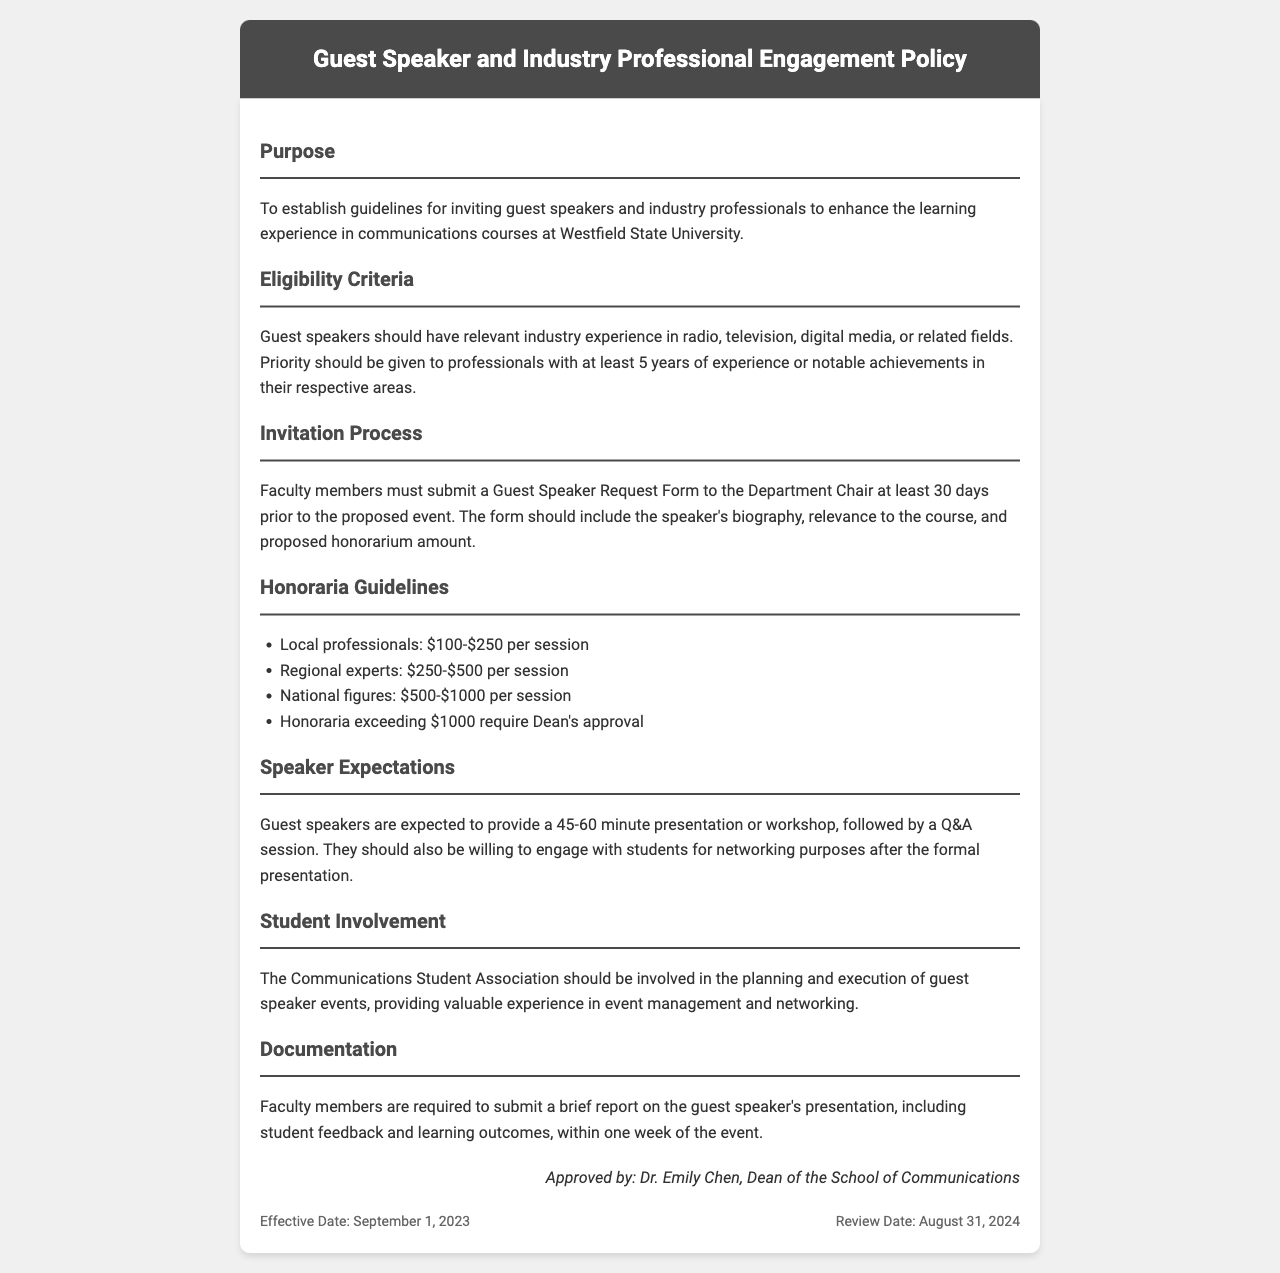What is the purpose of the document? The purpose is to establish guidelines for inviting guest speakers and industry professionals to enhance the learning experience in communications courses at Westfield State University.
Answer: Establish guidelines for inviting guest speakers Who has the final approval for honoraria exceeding $1000? The document states that honoraria exceeding $1000 require Dean's approval.
Answer: Dean's approval What is the recommended honorarium range for local professionals? The document specifies that local professionals should receive $100-$250 per session.
Answer: $100-$250 How long should guest speakers' presentations last? The document indicates that guest speakers are expected to provide a 45-60 minute presentation or workshop.
Answer: 45-60 minutes When must faculty members submit the Guest Speaker Request Form? Faculty members must submit the form at least 30 days prior to the proposed event.
Answer: 30 days What organization should be involved in planning guest speaker events? The document mentions that the Communications Student Association should be involved in the planning and execution of events.
Answer: Communications Student Association What is the effective date of the policy? The effective date of the policy is September 1, 2023.
Answer: September 1, 2023 What type of report must faculty submit after a guest speaker event? Faculty members are required to submit a brief report on the guest speaker's presentation.
Answer: Brief report Who approved the document? The document states that it was approved by Dr. Emily Chen, Dean of the School of Communications.
Answer: Dr. Emily Chen 